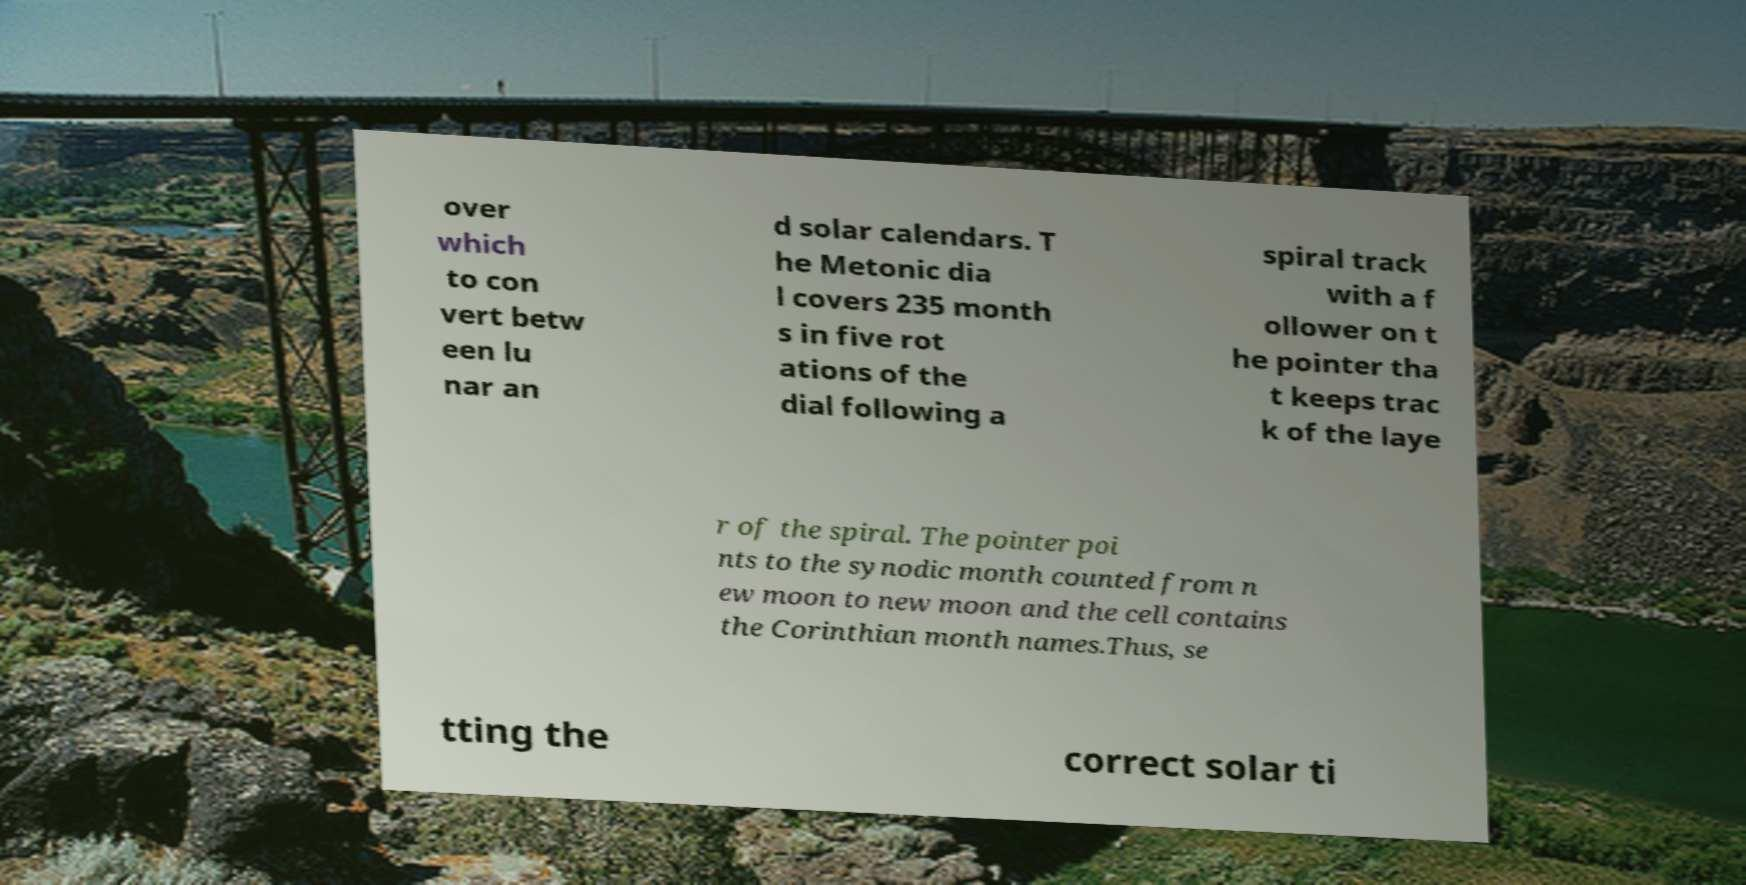I need the written content from this picture converted into text. Can you do that? over which to con vert betw een lu nar an d solar calendars. T he Metonic dia l covers 235 month s in five rot ations of the dial following a spiral track with a f ollower on t he pointer tha t keeps trac k of the laye r of the spiral. The pointer poi nts to the synodic month counted from n ew moon to new moon and the cell contains the Corinthian month names.Thus, se tting the correct solar ti 